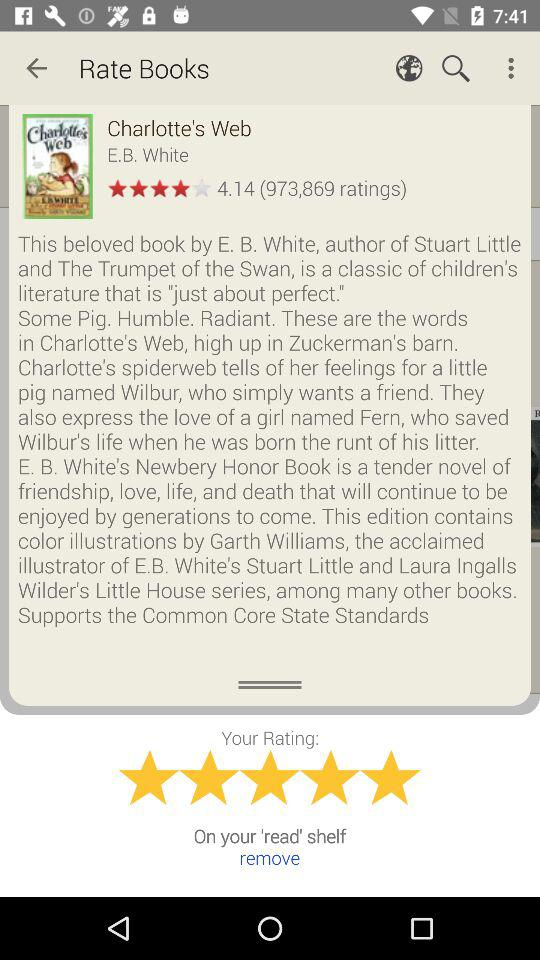What is the name of the girl? The name of the girl Charlotte. 